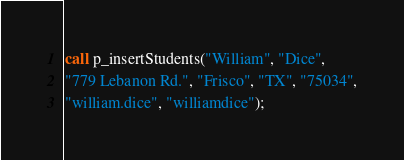<code> <loc_0><loc_0><loc_500><loc_500><_SQL_>call p_insertStudents("William", "Dice",
"779 Lebanon Rd.", "Frisco", "TX", "75034",
"william.dice", "williamdice");</code> 